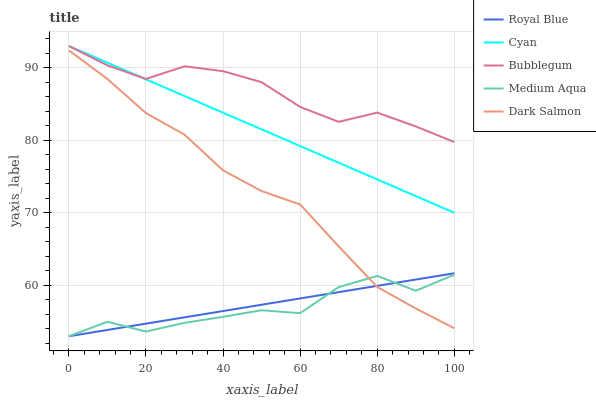Does Dark Salmon have the minimum area under the curve?
Answer yes or no. No. Does Dark Salmon have the maximum area under the curve?
Answer yes or no. No. Is Dark Salmon the smoothest?
Answer yes or no. No. Is Dark Salmon the roughest?
Answer yes or no. No. Does Dark Salmon have the lowest value?
Answer yes or no. No. Does Dark Salmon have the highest value?
Answer yes or no. No. Is Royal Blue less than Cyan?
Answer yes or no. Yes. Is Cyan greater than Medium Aqua?
Answer yes or no. Yes. Does Royal Blue intersect Cyan?
Answer yes or no. No. 